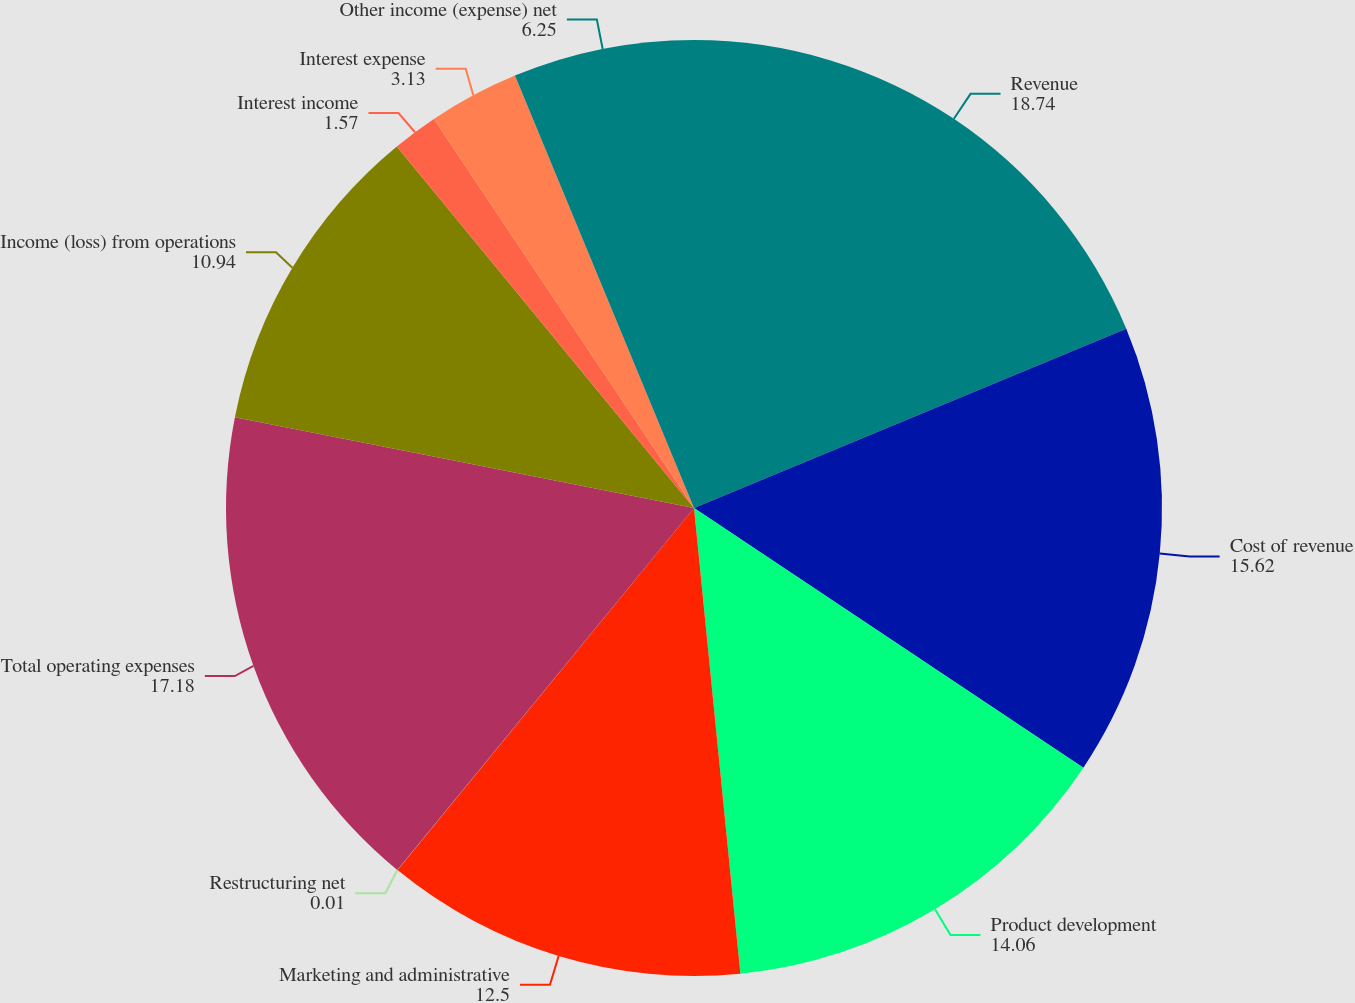Convert chart to OTSL. <chart><loc_0><loc_0><loc_500><loc_500><pie_chart><fcel>Revenue<fcel>Cost of revenue<fcel>Product development<fcel>Marketing and administrative<fcel>Restructuring net<fcel>Total operating expenses<fcel>Income (loss) from operations<fcel>Interest income<fcel>Interest expense<fcel>Other income (expense) net<nl><fcel>18.74%<fcel>15.62%<fcel>14.06%<fcel>12.5%<fcel>0.01%<fcel>17.18%<fcel>10.94%<fcel>1.57%<fcel>3.13%<fcel>6.25%<nl></chart> 